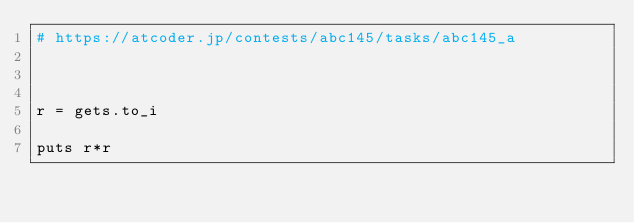<code> <loc_0><loc_0><loc_500><loc_500><_Ruby_># https://atcoder.jp/contests/abc145/tasks/abc145_a



r = gets.to_i

puts r*r
</code> 